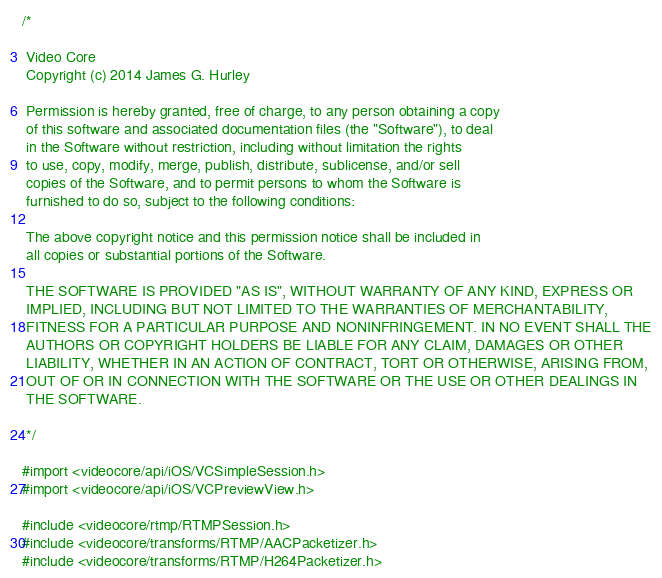<code> <loc_0><loc_0><loc_500><loc_500><_ObjectiveC_>/*

 Video Core
 Copyright (c) 2014 James G. Hurley

 Permission is hereby granted, free of charge, to any person obtaining a copy
 of this software and associated documentation files (the "Software"), to deal
 in the Software without restriction, including without limitation the rights
 to use, copy, modify, merge, publish, distribute, sublicense, and/or sell
 copies of the Software, and to permit persons to whom the Software is
 furnished to do so, subject to the following conditions:

 The above copyright notice and this permission notice shall be included in
 all copies or substantial portions of the Software.

 THE SOFTWARE IS PROVIDED "AS IS", WITHOUT WARRANTY OF ANY KIND, EXPRESS OR
 IMPLIED, INCLUDING BUT NOT LIMITED TO THE WARRANTIES OF MERCHANTABILITY,
 FITNESS FOR A PARTICULAR PURPOSE AND NONINFRINGEMENT. IN NO EVENT SHALL THE
 AUTHORS OR COPYRIGHT HOLDERS BE LIABLE FOR ANY CLAIM, DAMAGES OR OTHER
 LIABILITY, WHETHER IN AN ACTION OF CONTRACT, TORT OR OTHERWISE, ARISING FROM,
 OUT OF OR IN CONNECTION WITH THE SOFTWARE OR THE USE OR OTHER DEALINGS IN
 THE SOFTWARE.

 */

#import <videocore/api/iOS/VCSimpleSession.h>
#import <videocore/api/iOS/VCPreviewView.h>

#include <videocore/rtmp/RTMPSession.h>
#include <videocore/transforms/RTMP/AACPacketizer.h>
#include <videocore/transforms/RTMP/H264Packetizer.h></code> 